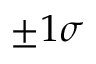<formula> <loc_0><loc_0><loc_500><loc_500>\pm 1 \sigma</formula> 